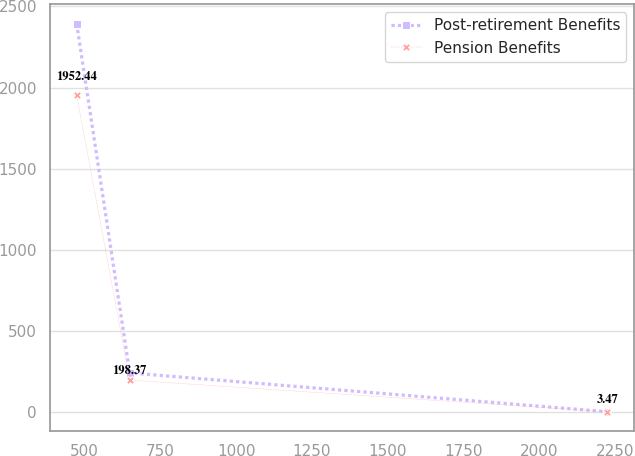Convert chart to OTSL. <chart><loc_0><loc_0><loc_500><loc_500><line_chart><ecel><fcel>Post-retirement Benefits<fcel>Pension Benefits<nl><fcel>473.86<fcel>2393.41<fcel>1952.44<nl><fcel>649<fcel>242.6<fcel>198.37<nl><fcel>2225.29<fcel>3.62<fcel>3.47<nl></chart> 